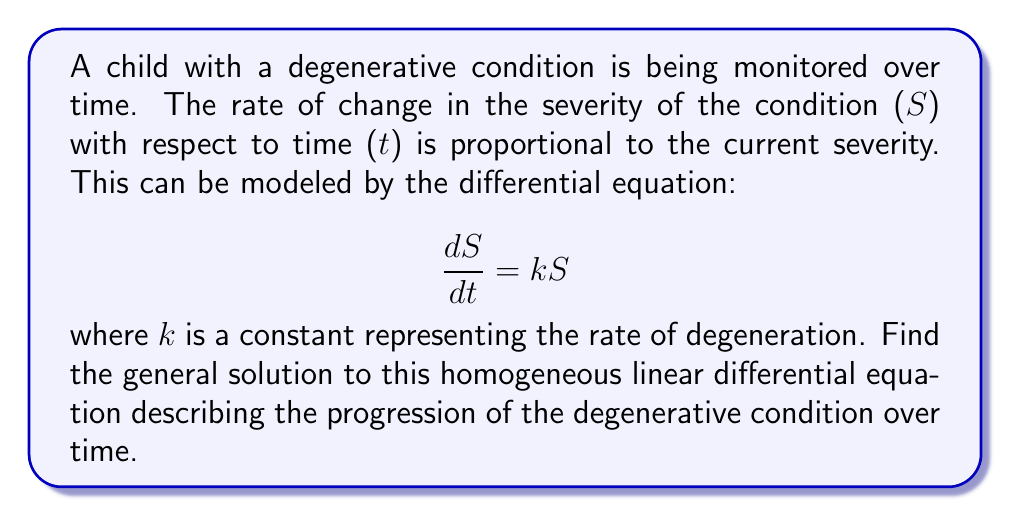Can you answer this question? To solve this homogeneous linear differential equation, we'll follow these steps:

1) First, we recognize that this is a separable differential equation. We can separate the variables S and t:

   $$\frac{dS}{S} = k \, dt$$

2) Now, we integrate both sides:

   $$\int \frac{dS}{S} = \int k \, dt$$

3) The left-hand side integrates to the natural logarithm of S, and the right-hand side integrates to kt plus a constant:

   $$\ln|S| = kt + C$$

   where C is an arbitrary constant of integration.

4) To solve for S, we exponentiate both sides:

   $$e^{\ln|S|} = e^{kt + C}$$

5) Simplify the left side:

   $$|S| = e^{kt + C}$$

6) We can rewrite this as:

   $$|S| = e^{kt} \cdot e^C$$

7) Since $e^C$ is a positive constant, we can absorb the absolute value signs and represent this constant as A. Our final solution is:

   $$S = Ae^{kt}$$

   where A is an arbitrary positive constant.

This solution represents the severity of the condition at any time t, given an initial severity (represented by A) and a rate of degeneration k.
Answer: The general solution to the differential equation $\frac{dS}{dt} = kS$ is:

$$S = Ae^{kt}$$

where A is an arbitrary positive constant and k is the rate of degeneration. 